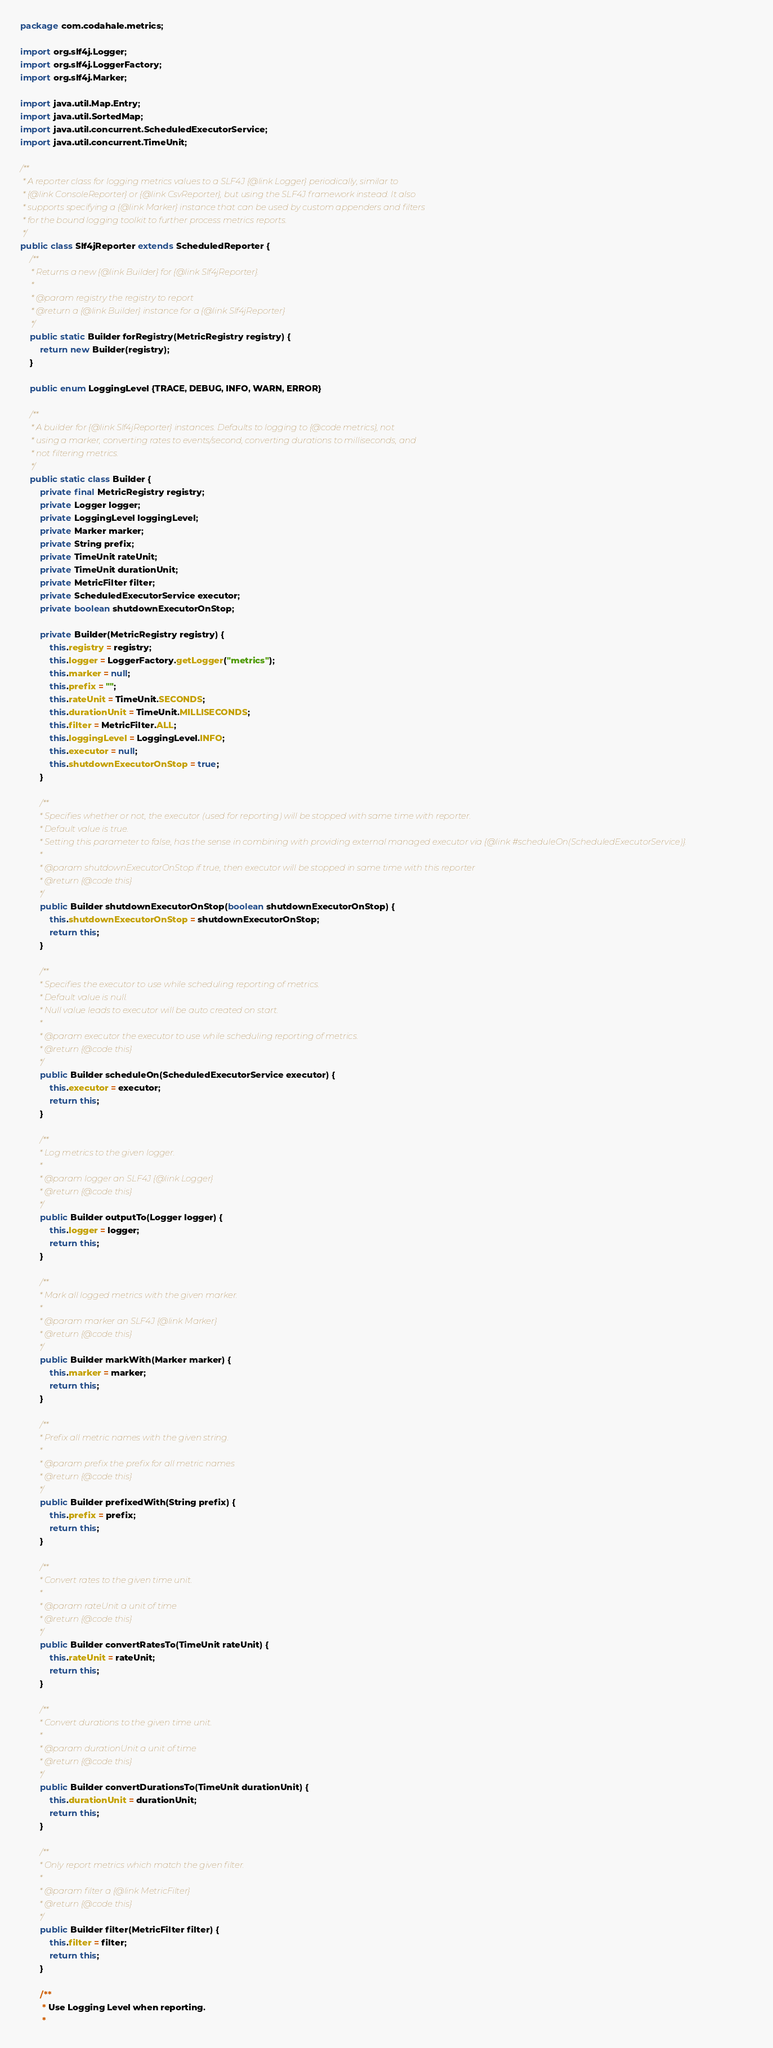Convert code to text. <code><loc_0><loc_0><loc_500><loc_500><_Java_>package com.codahale.metrics;

import org.slf4j.Logger;
import org.slf4j.LoggerFactory;
import org.slf4j.Marker;

import java.util.Map.Entry;
import java.util.SortedMap;
import java.util.concurrent.ScheduledExecutorService;
import java.util.concurrent.TimeUnit;

/**
 * A reporter class for logging metrics values to a SLF4J {@link Logger} periodically, similar to
 * {@link ConsoleReporter} or {@link CsvReporter}, but using the SLF4J framework instead. It also
 * supports specifying a {@link Marker} instance that can be used by custom appenders and filters
 * for the bound logging toolkit to further process metrics reports.
 */
public class Slf4jReporter extends ScheduledReporter {
    /**
     * Returns a new {@link Builder} for {@link Slf4jReporter}.
     *
     * @param registry the registry to report
     * @return a {@link Builder} instance for a {@link Slf4jReporter}
     */
    public static Builder forRegistry(MetricRegistry registry) {
        return new Builder(registry);
    }

    public enum LoggingLevel {TRACE, DEBUG, INFO, WARN, ERROR}

    /**
     * A builder for {@link Slf4jReporter} instances. Defaults to logging to {@code metrics}, not
     * using a marker, converting rates to events/second, converting durations to milliseconds, and
     * not filtering metrics.
     */
    public static class Builder {
        private final MetricRegistry registry;
        private Logger logger;
        private LoggingLevel loggingLevel;
        private Marker marker;
        private String prefix;
        private TimeUnit rateUnit;
        private TimeUnit durationUnit;
        private MetricFilter filter;
        private ScheduledExecutorService executor;
        private boolean shutdownExecutorOnStop;

        private Builder(MetricRegistry registry) {
            this.registry = registry;
            this.logger = LoggerFactory.getLogger("metrics");
            this.marker = null;
            this.prefix = "";
            this.rateUnit = TimeUnit.SECONDS;
            this.durationUnit = TimeUnit.MILLISECONDS;
            this.filter = MetricFilter.ALL;
            this.loggingLevel = LoggingLevel.INFO;
            this.executor = null;
            this.shutdownExecutorOnStop = true;
        }

        /**
         * Specifies whether or not, the executor (used for reporting) will be stopped with same time with reporter.
         * Default value is true.
         * Setting this parameter to false, has the sense in combining with providing external managed executor via {@link #scheduleOn(ScheduledExecutorService)}.
         *
         * @param shutdownExecutorOnStop if true, then executor will be stopped in same time with this reporter
         * @return {@code this}
         */
        public Builder shutdownExecutorOnStop(boolean shutdownExecutorOnStop) {
            this.shutdownExecutorOnStop = shutdownExecutorOnStop;
            return this;
        }

        /**
         * Specifies the executor to use while scheduling reporting of metrics.
         * Default value is null.
         * Null value leads to executor will be auto created on start.
         *
         * @param executor the executor to use while scheduling reporting of metrics.
         * @return {@code this}
         */
        public Builder scheduleOn(ScheduledExecutorService executor) {
            this.executor = executor;
            return this;
        }

        /**
         * Log metrics to the given logger.
         *
         * @param logger an SLF4J {@link Logger}
         * @return {@code this}
         */
        public Builder outputTo(Logger logger) {
            this.logger = logger;
            return this;
        }

        /**
         * Mark all logged metrics with the given marker.
         *
         * @param marker an SLF4J {@link Marker}
         * @return {@code this}
         */
        public Builder markWith(Marker marker) {
            this.marker = marker;
            return this;
        }

        /**
         * Prefix all metric names with the given string.
         *
         * @param prefix the prefix for all metric names
         * @return {@code this}
         */
        public Builder prefixedWith(String prefix) {
            this.prefix = prefix;
            return this;
        }

        /**
         * Convert rates to the given time unit.
         *
         * @param rateUnit a unit of time
         * @return {@code this}
         */
        public Builder convertRatesTo(TimeUnit rateUnit) {
            this.rateUnit = rateUnit;
            return this;
        }

        /**
         * Convert durations to the given time unit.
         *
         * @param durationUnit a unit of time
         * @return {@code this}
         */
        public Builder convertDurationsTo(TimeUnit durationUnit) {
            this.durationUnit = durationUnit;
            return this;
        }

        /**
         * Only report metrics which match the given filter.
         *
         * @param filter a {@link MetricFilter}
         * @return {@code this}
         */
        public Builder filter(MetricFilter filter) {
            this.filter = filter;
            return this;
        }

        /**
         * Use Logging Level when reporting.
         *</code> 